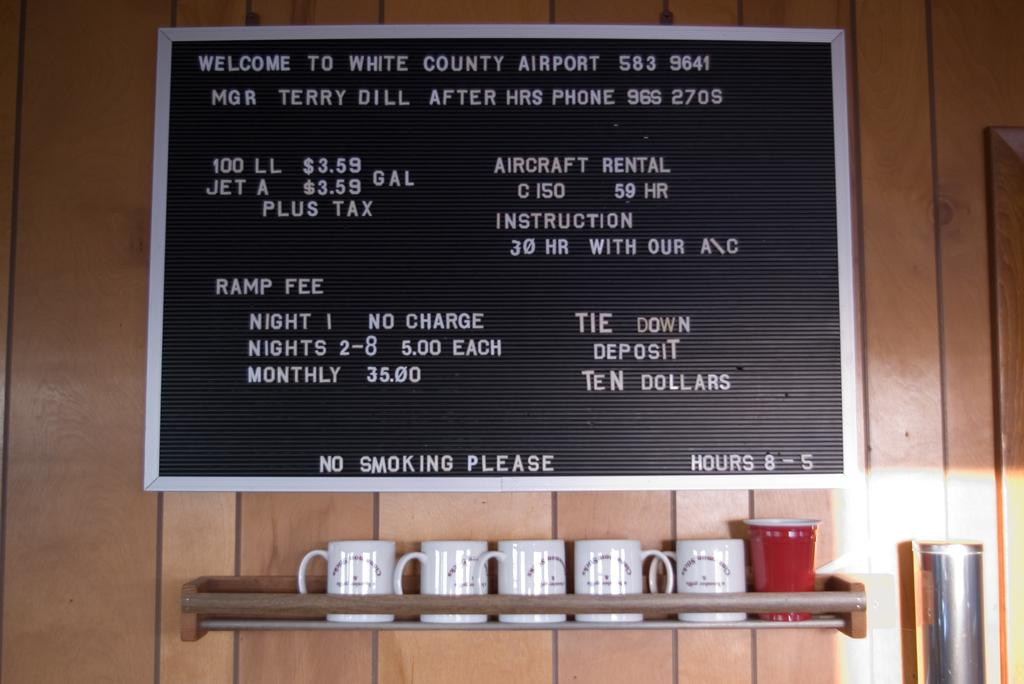What objects are located at the bottom of the image? There are cups at the bottom of the image. What can be seen in the middle of the image? There is a board with text in the middle of the image. How many boys are sitting on the tongue in the image? There is no tongue or boys present in the image. What type of prose is written on the board in the image? The provided facts do not mention any specific type of prose or text on the board, so we cannot determine the type of prose from the image. 